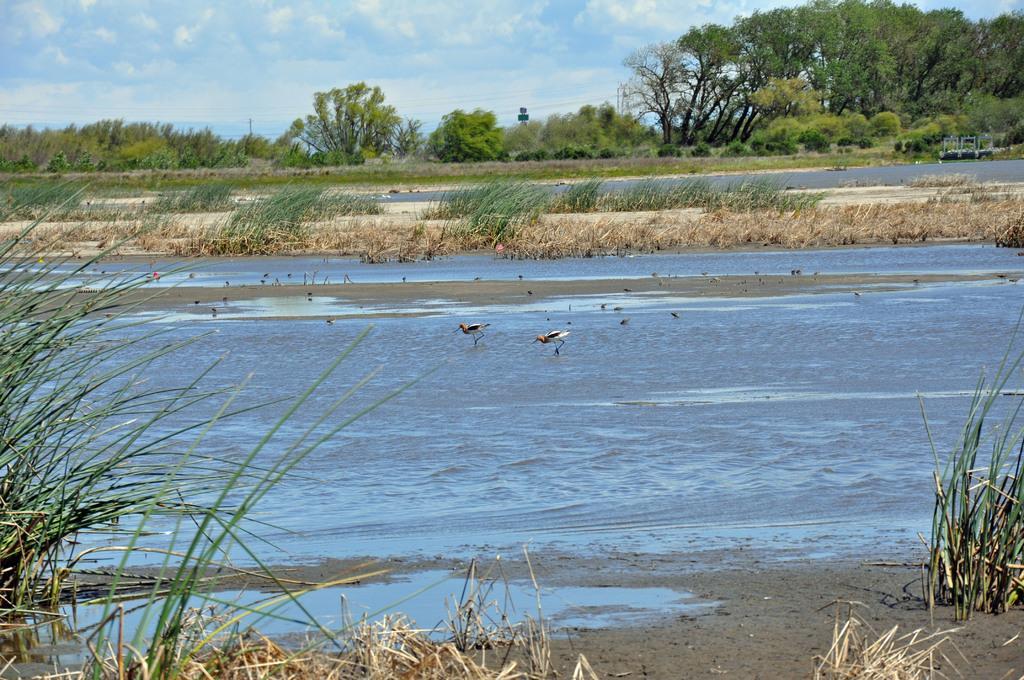Could you give a brief overview of what you see in this image? In this image we can see there are birds, trees, grass, plants and water. In the background we can see cloudy sky. 